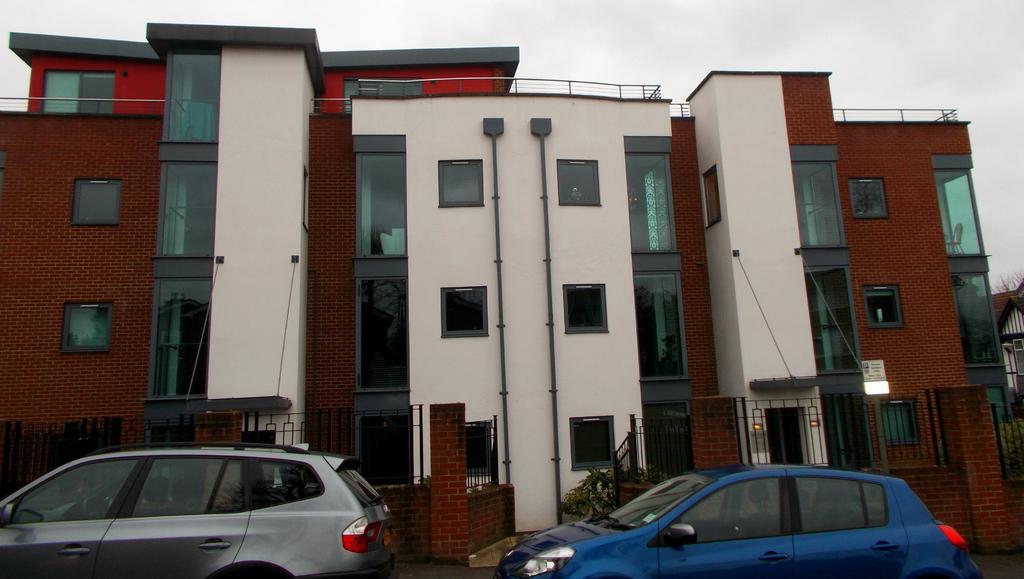In one or two sentences, can you explain what this image depicts? In this image in the center there are some buildings, railing, wall and at the bottom there are two vehicles. And at the top of the image there is sky. 